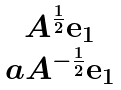Convert formula to latex. <formula><loc_0><loc_0><loc_500><loc_500>\begin{matrix} A ^ { \frac { 1 } { 2 } } { \mathbf e } _ { 1 } \\ a A ^ { - \frac { 1 } { 2 } } { \mathbf e } _ { 1 } \end{matrix}</formula> 